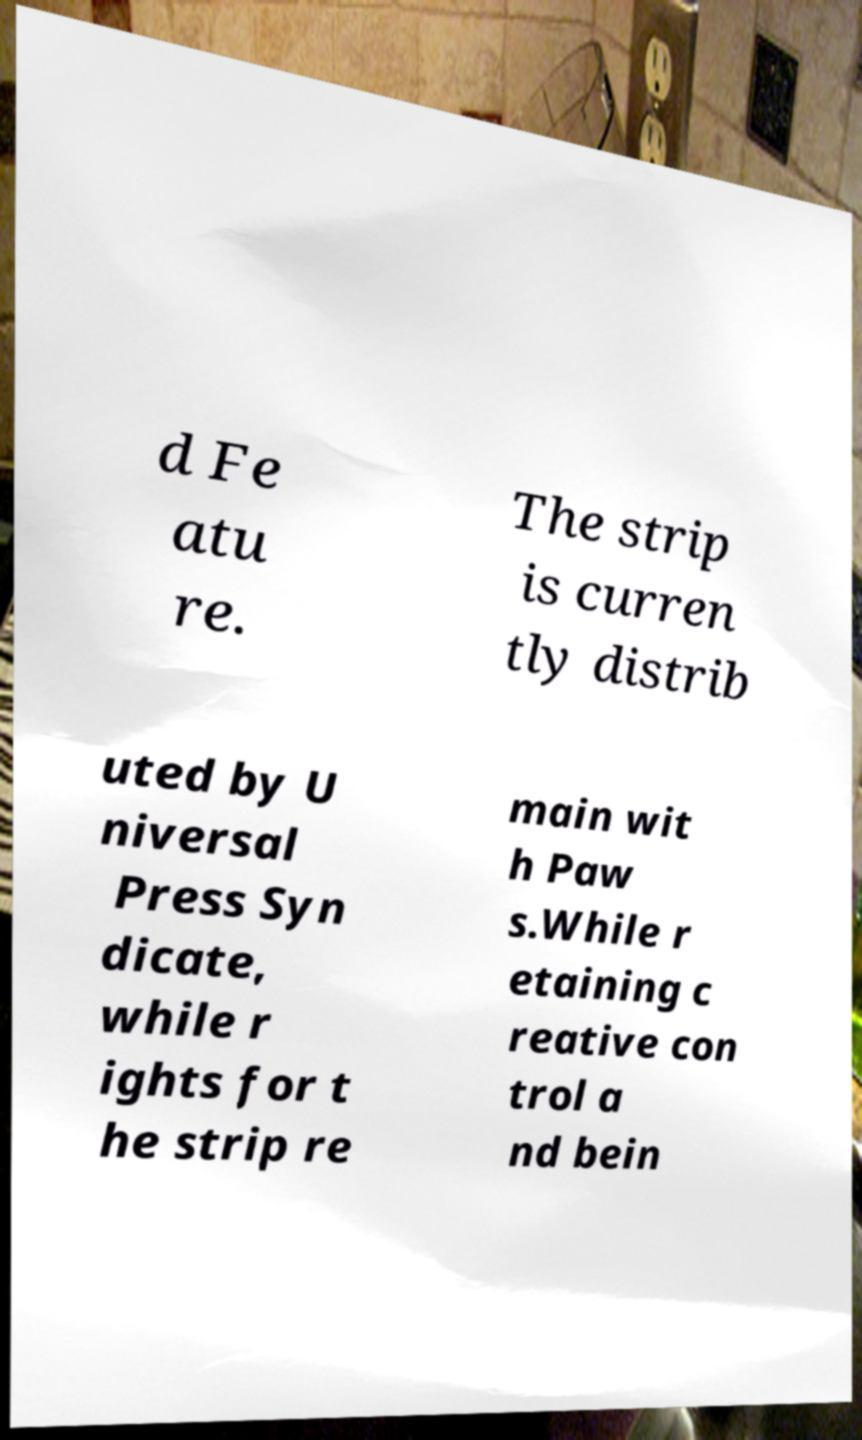Could you extract and type out the text from this image? d Fe atu re. The strip is curren tly distrib uted by U niversal Press Syn dicate, while r ights for t he strip re main wit h Paw s.While r etaining c reative con trol a nd bein 